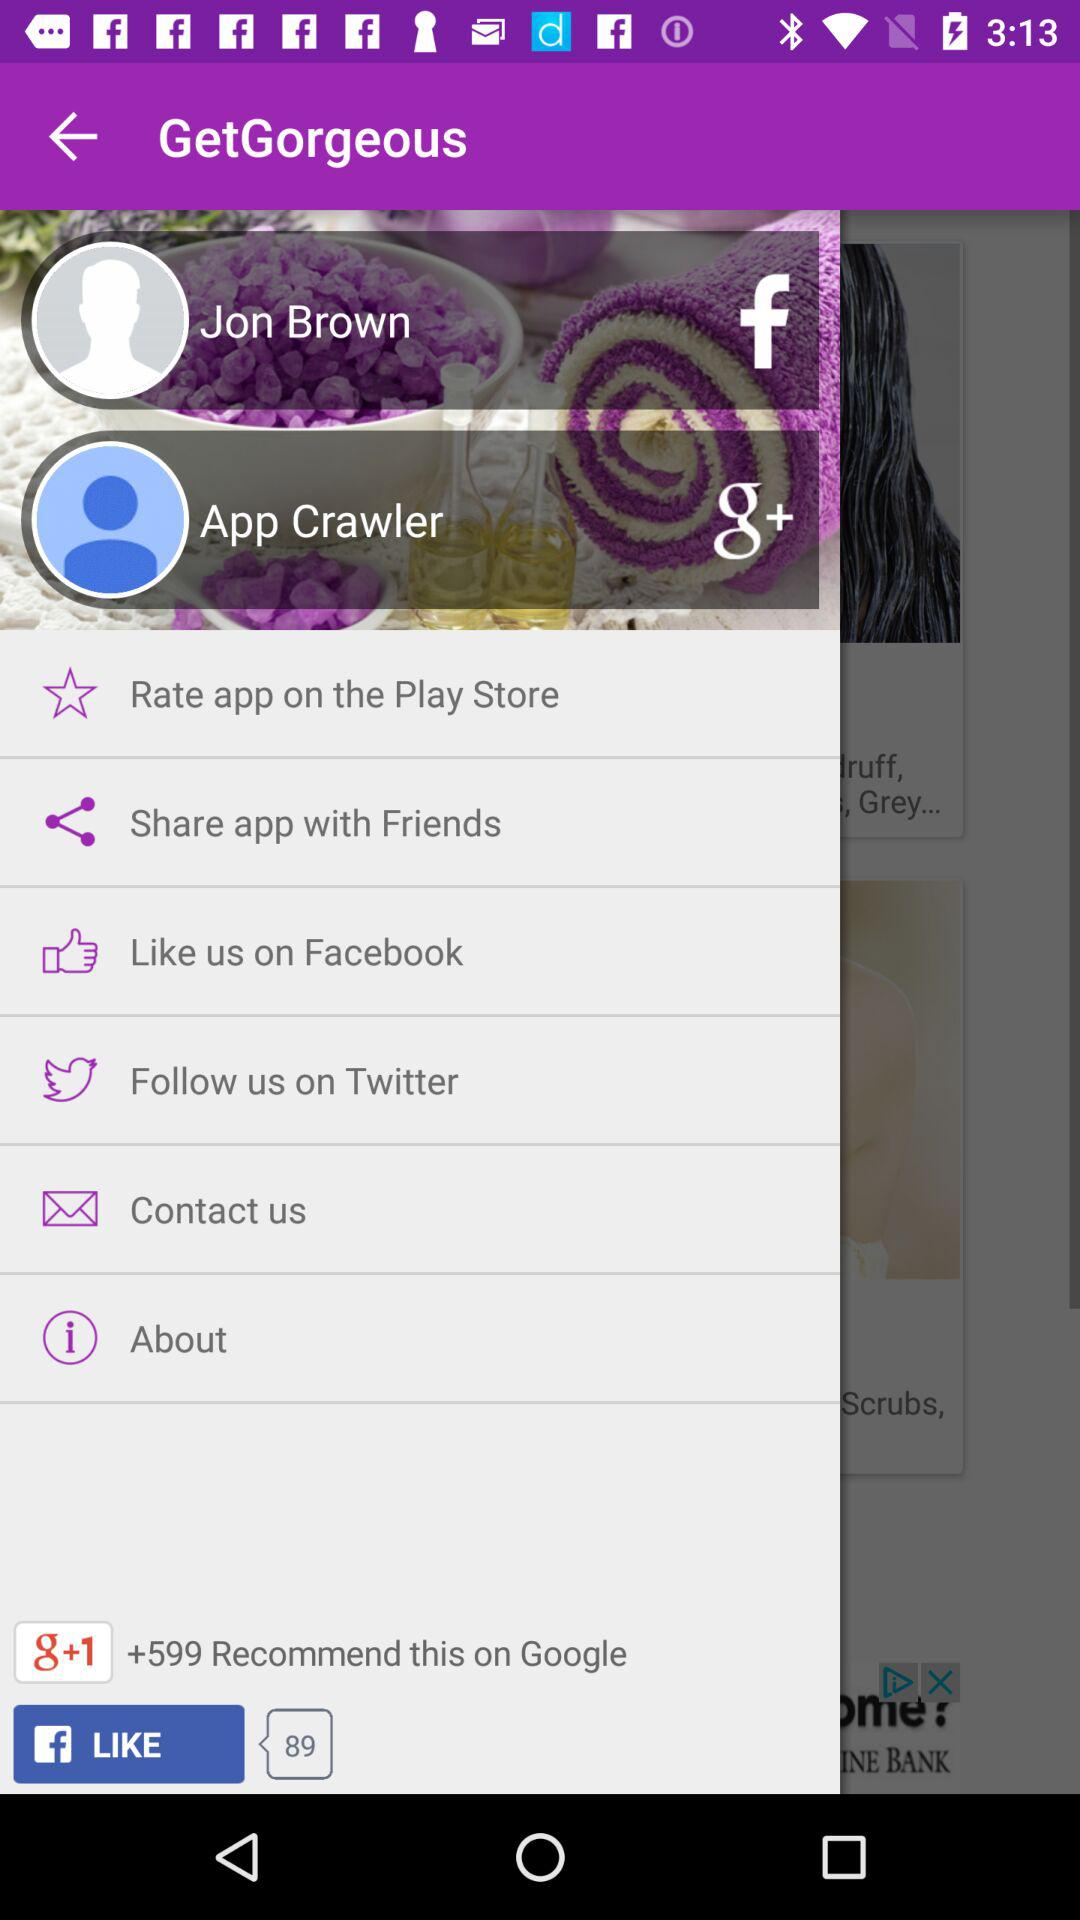What is the user name for "Facebook"? The user name for "Facebook" is Jon Brown. 